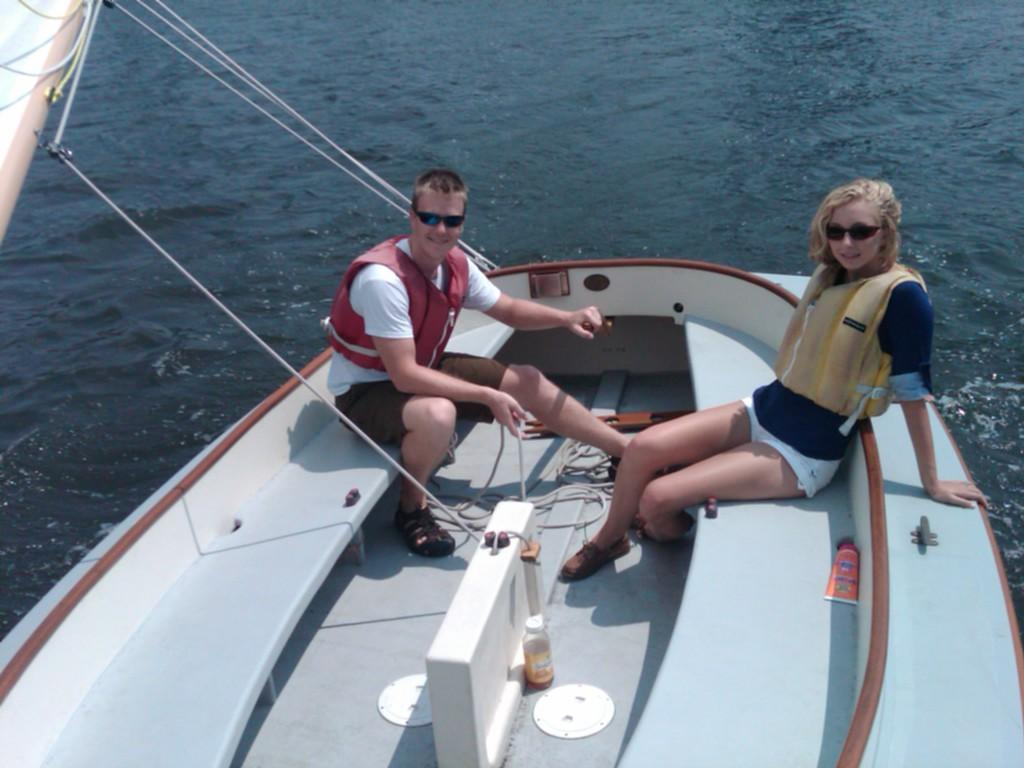Who can be seen in the foreground of the picture? There is a couple in the foreground of the picture. What are the couple doing in the image? The couple is sitting on a boat. What can be seen in the background of the image? There is water visible in the background of the image. What type of statement is the grandmother making in the image? There is no grandmother present in the image, and therefore no statement can be attributed to her. 